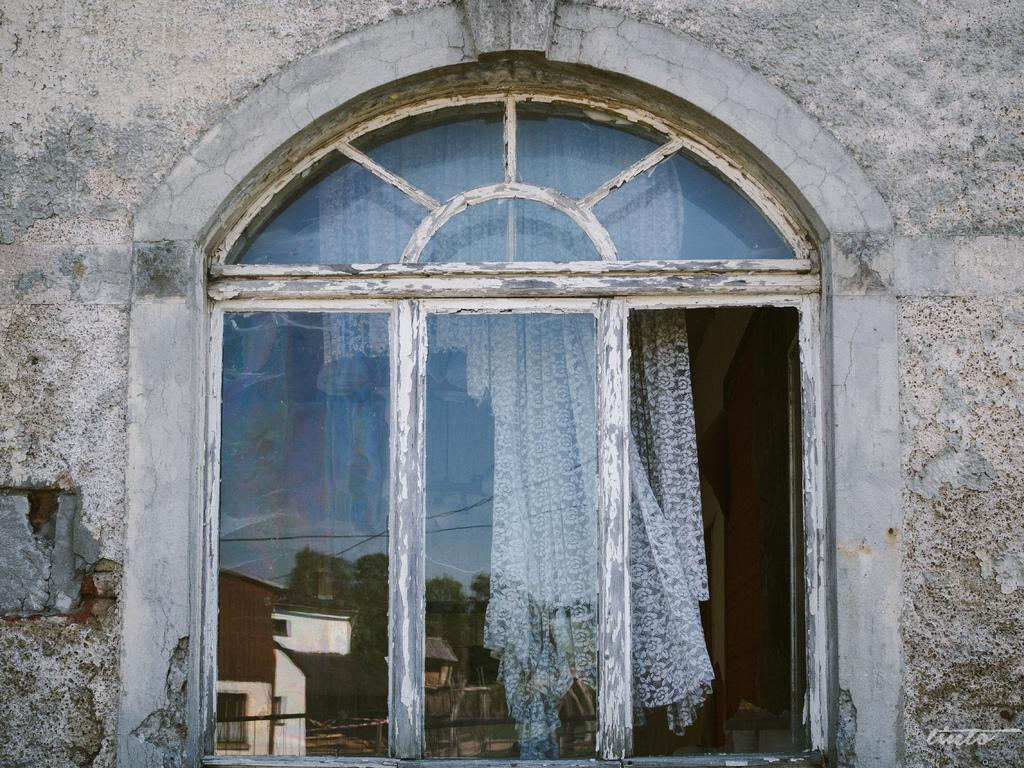What type of structure is present in the image? There is a glass window and a wall in the image. What can be seen through the glass window? A curtain is visible through the glass window. What reflections can be observed on the glass window? The reflections of houses, trees, rooftops, the sky, and railing are visible on the glass window. What type of disease is present in the image? There is no disease present in the image; it features a glass window, a wall, and various reflections. What direction is the land facing in the image? The image does not depict a specific direction or land; it focuses on the glass window and its reflections. 